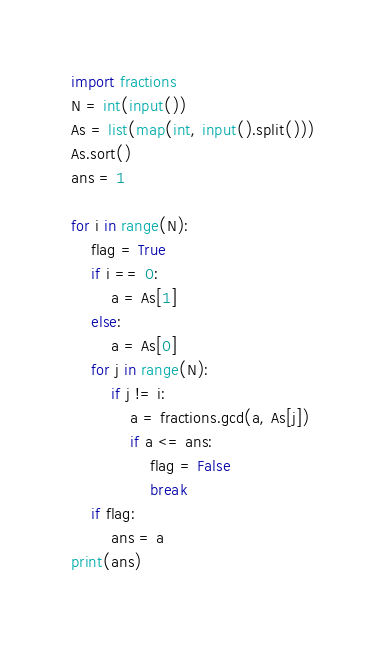Convert code to text. <code><loc_0><loc_0><loc_500><loc_500><_Python_>import fractions
N = int(input())
As = list(map(int, input().split()))
As.sort()
ans = 1

for i in range(N):
    flag = True
    if i == 0:
        a = As[1]
    else:
        a = As[0]
    for j in range(N):
        if j != i:
            a = fractions.gcd(a, As[j])
            if a <= ans:
                flag = False
                break
    if flag:
        ans = a
print(ans)
        </code> 